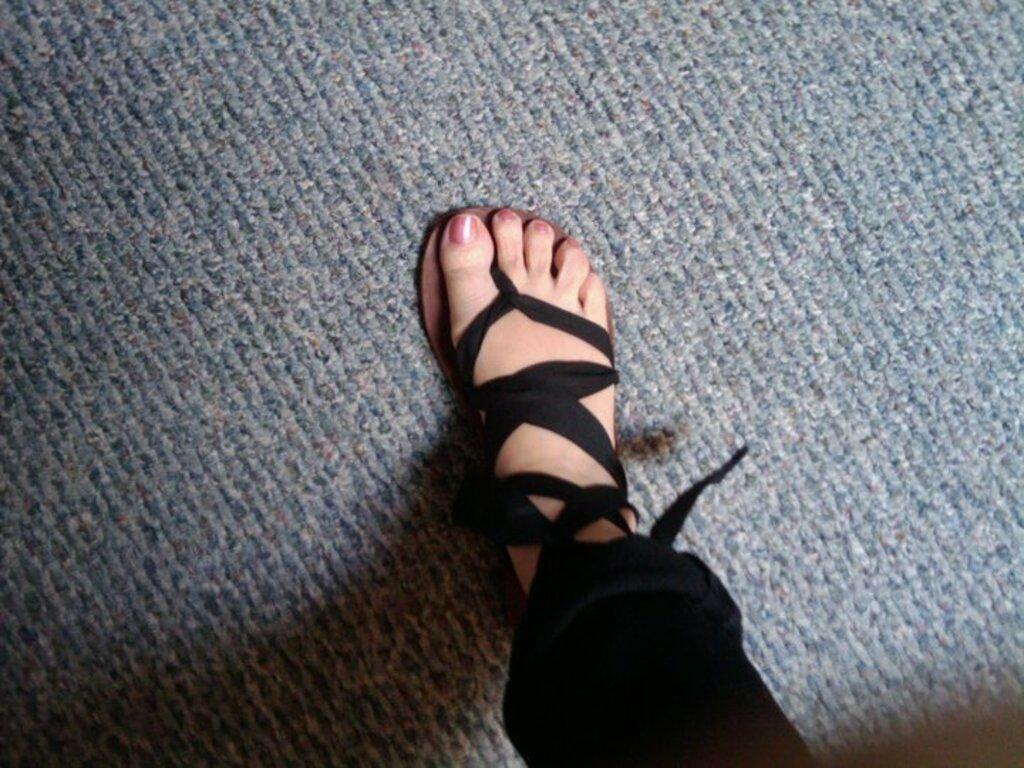What part of a person can be seen in the image? There is a leg of a person visible in the image. Where is the leg located in the image? The leg is in the center of the image. What flavor of ice cream is being held by the person whose leg is visible in the image? There is no ice cream or indication of ice cream in the image, so it is not possible to determine the flavor. 